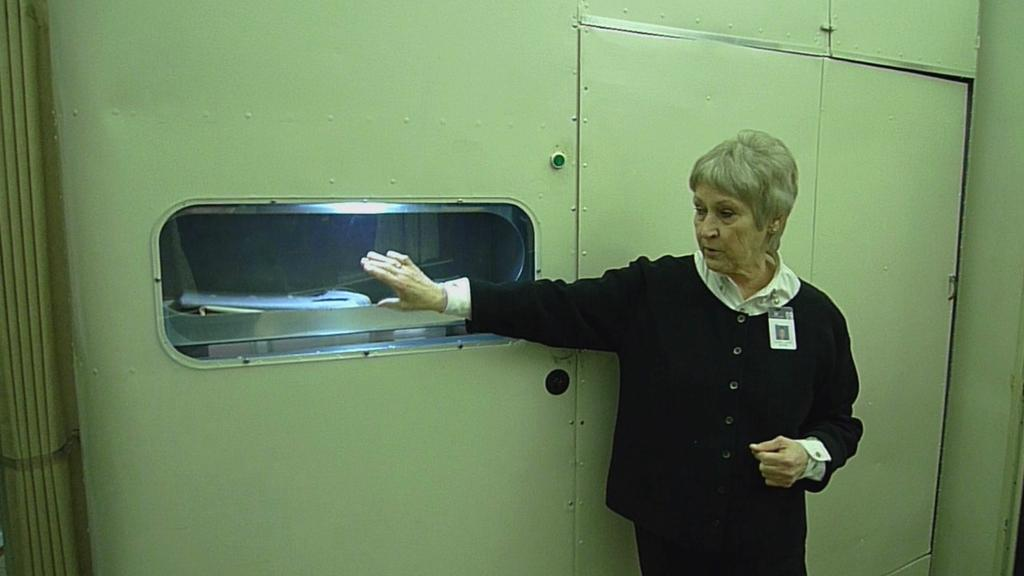Who is the main subject in the image? There is a woman in the image. What is the woman doing in the image? The woman is standing in front of a door. What is the woman holding in the image? The woman is holding a window. What type of furniture can be seen in the image? There is no furniture present in the image. Can you describe the woman's toe in the image? There is no specific detail about the woman's toe mentioned in the facts, so it cannot be described. 